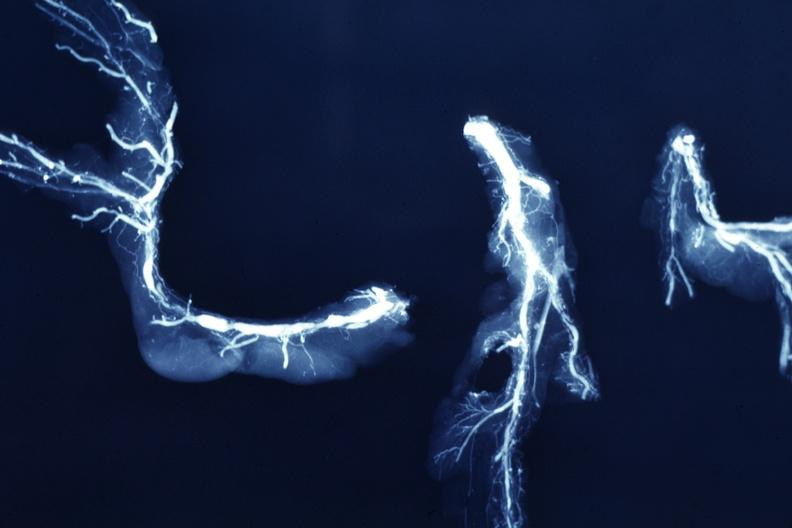s coronary artery present?
Answer the question using a single word or phrase. Yes 